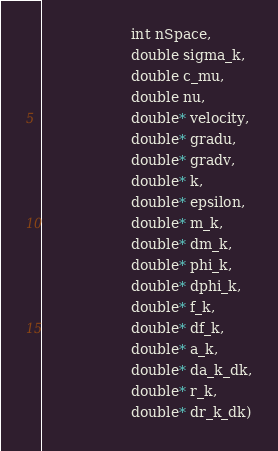Convert code to text. <code><loc_0><loc_0><loc_500><loc_500><_Cython_>                    int nSpace,
                    double sigma_k,
                    double c_mu,
                    double nu,
                    double* velocity,
                    double* gradu,
                    double* gradv,
                    double* k,
                    double* epsilon,
                    double* m_k,
                    double* dm_k,
                    double* phi_k,
                    double* dphi_k,
                    double* f_k,
                    double* df_k,
                    double* a_k,
                    double* da_k_dk,
                    double* r_k,
                    double* dr_k_dk)</code> 